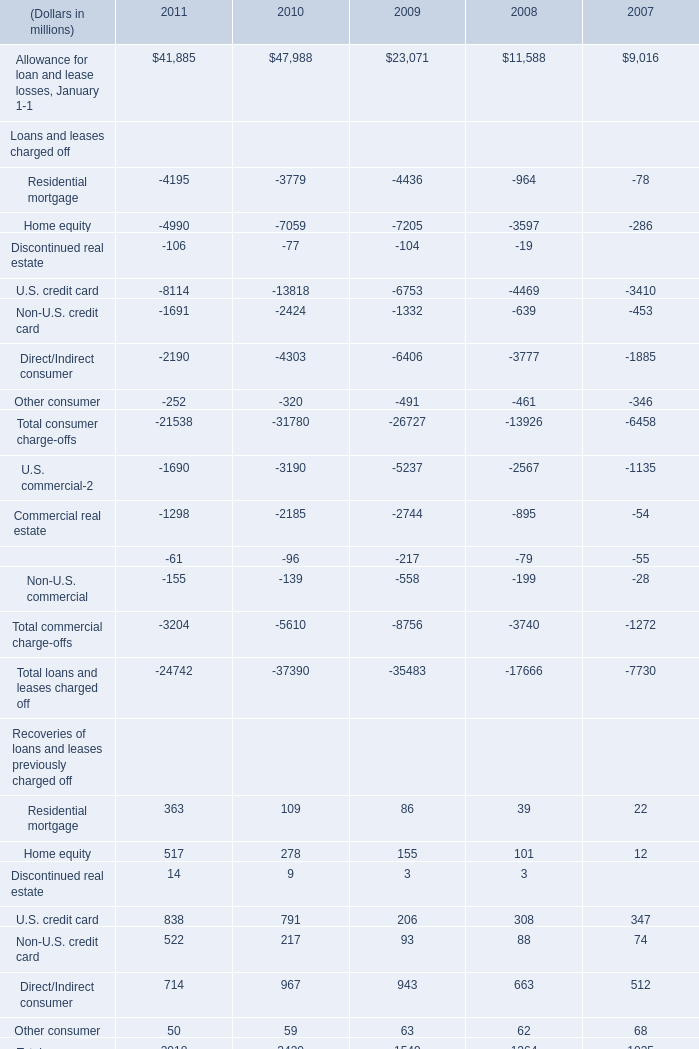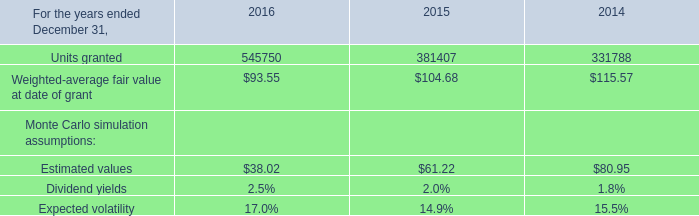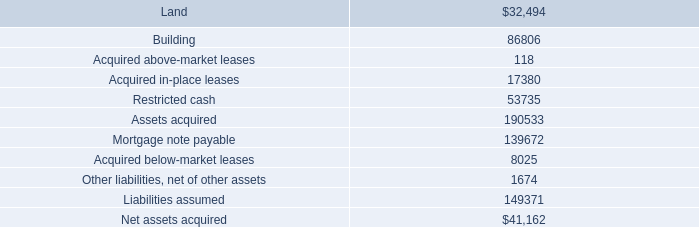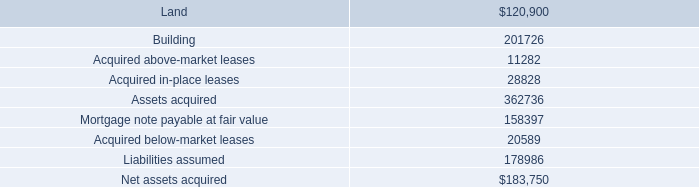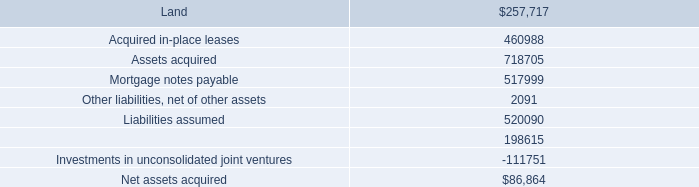What's the sum of U.S. commercial Loans and leases charged off of 2008, Mortgage note payable at fair value, and Units granted of 2015 ? 
Computations: ((2567.0 + 158397.0) + 381407.0)
Answer: 542371.0. 